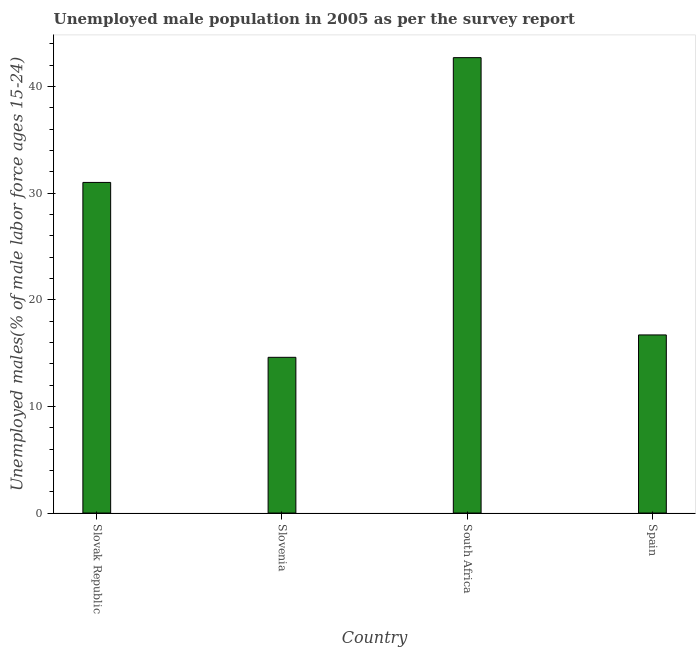Does the graph contain grids?
Give a very brief answer. No. What is the title of the graph?
Make the answer very short. Unemployed male population in 2005 as per the survey report. What is the label or title of the Y-axis?
Your answer should be compact. Unemployed males(% of male labor force ages 15-24). What is the unemployed male youth in Slovenia?
Make the answer very short. 14.6. Across all countries, what is the maximum unemployed male youth?
Your answer should be very brief. 42.7. Across all countries, what is the minimum unemployed male youth?
Offer a terse response. 14.6. In which country was the unemployed male youth maximum?
Give a very brief answer. South Africa. In which country was the unemployed male youth minimum?
Give a very brief answer. Slovenia. What is the sum of the unemployed male youth?
Your response must be concise. 105. What is the average unemployed male youth per country?
Your response must be concise. 26.25. What is the median unemployed male youth?
Keep it short and to the point. 23.85. In how many countries, is the unemployed male youth greater than 14 %?
Your response must be concise. 4. What is the ratio of the unemployed male youth in Slovenia to that in South Africa?
Make the answer very short. 0.34. Is the unemployed male youth in South Africa less than that in Spain?
Ensure brevity in your answer.  No. Is the difference between the unemployed male youth in South Africa and Spain greater than the difference between any two countries?
Provide a succinct answer. No. What is the difference between the highest and the lowest unemployed male youth?
Provide a succinct answer. 28.1. Are all the bars in the graph horizontal?
Provide a succinct answer. No. How many countries are there in the graph?
Offer a terse response. 4. What is the difference between two consecutive major ticks on the Y-axis?
Provide a succinct answer. 10. What is the Unemployed males(% of male labor force ages 15-24) of Slovak Republic?
Give a very brief answer. 31. What is the Unemployed males(% of male labor force ages 15-24) of Slovenia?
Offer a terse response. 14.6. What is the Unemployed males(% of male labor force ages 15-24) in South Africa?
Offer a terse response. 42.7. What is the Unemployed males(% of male labor force ages 15-24) in Spain?
Your response must be concise. 16.7. What is the difference between the Unemployed males(% of male labor force ages 15-24) in Slovak Republic and Slovenia?
Ensure brevity in your answer.  16.4. What is the difference between the Unemployed males(% of male labor force ages 15-24) in Slovak Republic and South Africa?
Your answer should be compact. -11.7. What is the difference between the Unemployed males(% of male labor force ages 15-24) in Slovenia and South Africa?
Keep it short and to the point. -28.1. What is the difference between the Unemployed males(% of male labor force ages 15-24) in Slovenia and Spain?
Offer a very short reply. -2.1. What is the difference between the Unemployed males(% of male labor force ages 15-24) in South Africa and Spain?
Make the answer very short. 26. What is the ratio of the Unemployed males(% of male labor force ages 15-24) in Slovak Republic to that in Slovenia?
Your answer should be very brief. 2.12. What is the ratio of the Unemployed males(% of male labor force ages 15-24) in Slovak Republic to that in South Africa?
Offer a terse response. 0.73. What is the ratio of the Unemployed males(% of male labor force ages 15-24) in Slovak Republic to that in Spain?
Your answer should be very brief. 1.86. What is the ratio of the Unemployed males(% of male labor force ages 15-24) in Slovenia to that in South Africa?
Keep it short and to the point. 0.34. What is the ratio of the Unemployed males(% of male labor force ages 15-24) in Slovenia to that in Spain?
Provide a succinct answer. 0.87. What is the ratio of the Unemployed males(% of male labor force ages 15-24) in South Africa to that in Spain?
Make the answer very short. 2.56. 